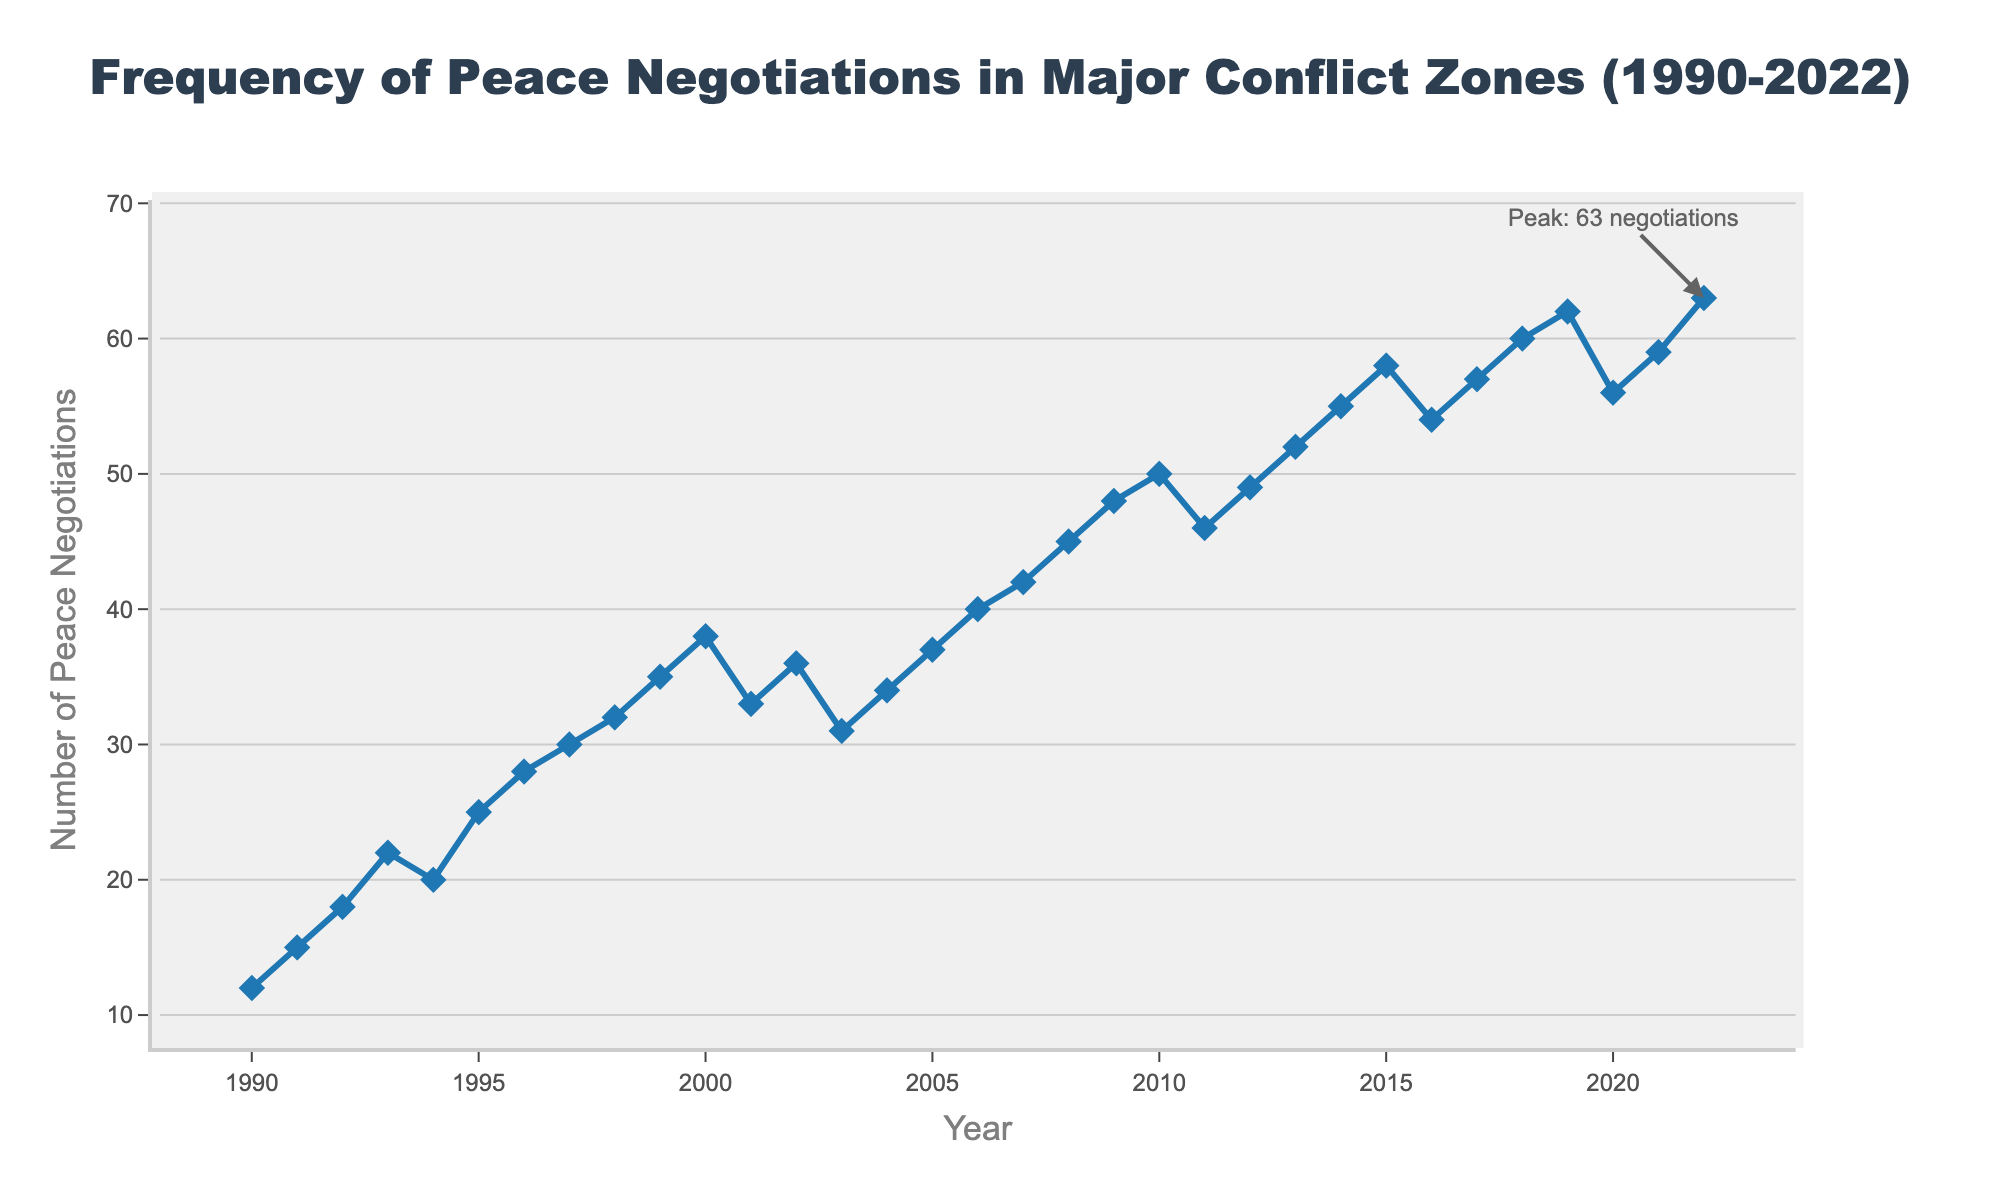What was the frequency of peace negotiations in 1995? Look at the data point corresponding to the year 1995 on the x-axis and read the value on the y-axis.
Answer: 25 In which years did the frequency of peace negotiations decrease from the previous year? Identify the years where the y-axis value is lower compared to the previous year by inspecting the trend line.
Answer: 2001, 2003, 2010, 2016, 2020 What is the difference in the number of peace negotiations between 1990 and 2022? Subtract the number of peace negotiations in 1990 from that in 2022, using the values from the respective years on the y-axis.
Answer: 51 What was the percentage increase in peace negotiations from 1990 to 2000? Calculate the increase from 1990 (12) to 2000 (38), then divide the increase by the 1990 value, and multiply by 100 to get the percentage. ((38 - 12) / 12) * 100
Answer: 216.67% Which year had the highest frequency of peace negotiations and what was the frequency? Look for the data point with the highest value on the y-axis and note the corresponding year on the x-axis as well as the value itself.
Answer: 2022, 63 By how much did the frequency of peace negotiations change from 2019 to 2020? Subtract the number of peace negotiations in 2020 from that in 2019 using the values from the respective years on the y-axis.
Answer: -6 Which decade saw the most significant overall increase in the number of peace negotiations? Split the years into decades (1990s, 2000s, 2010s, etc.), calculate the total increase for each decade by subtracting the initial year from the final year of each decade.
Answer: 2010s What is the average number of peace negotiations per year from 1990 to 2000? Add all the number of peace negotiations from each year between 1990 and 2000, inclusive, then divide by the number of years (11).  (12 + 15 + 18 + 22 + 20 + 25 + 28 + 30 + 32 + 35 + 38) / 11
Answer: 26.36 How many times did the frequency of peace negotiations hit a value greater than or equal to 50? Count all instances where the y-axis value is 50 or higher by inspecting the trend line numerically or visually.
Answer: 7 By what percentage did the number of peace negotiations decrease from 2022 to 2020? Calculate the decrease from 2022 (63) to 2020 (56), then divide the decrease by the 2022 value, and multiply by 100 to get the percentage. ((63 - 56) / 63) * 100
Answer: 11.11% 